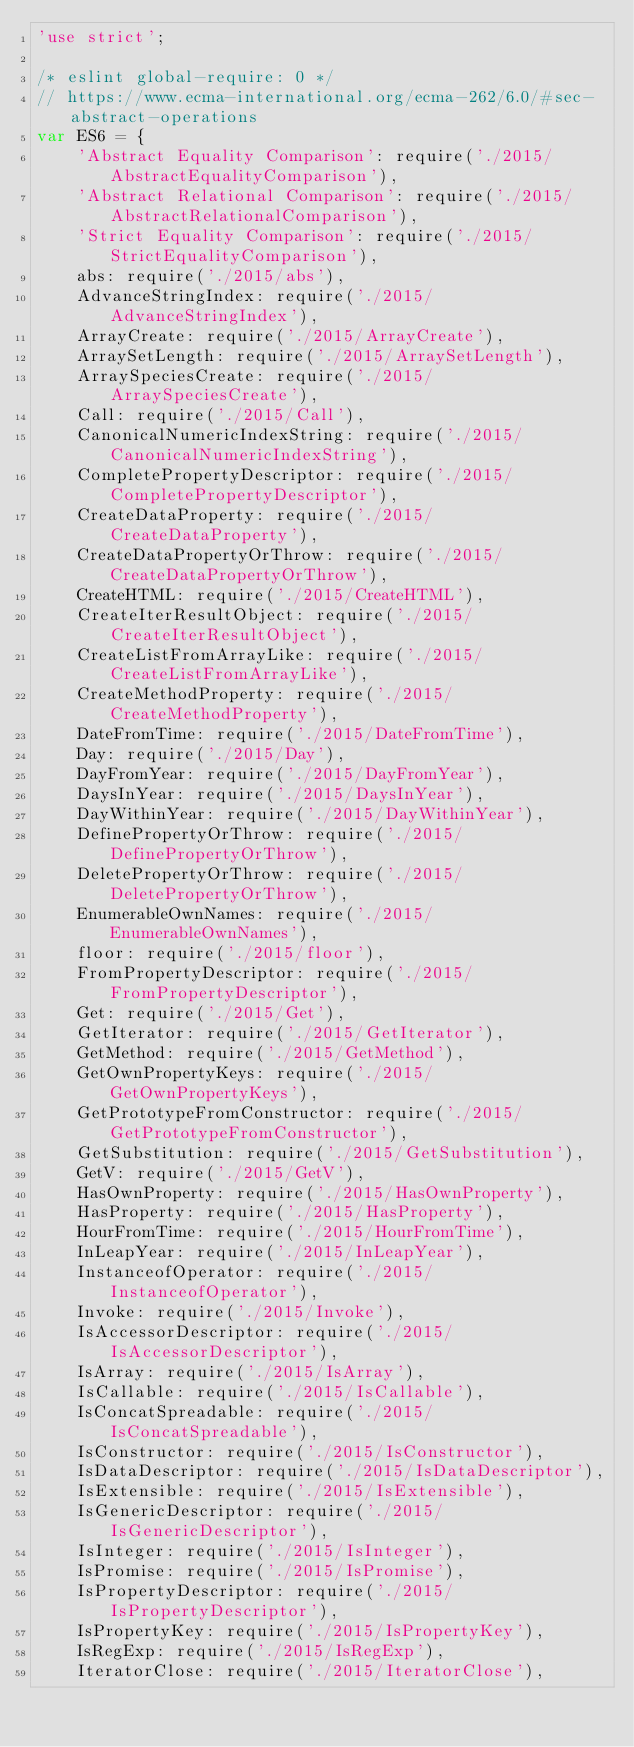<code> <loc_0><loc_0><loc_500><loc_500><_JavaScript_>'use strict';

/* eslint global-require: 0 */
// https://www.ecma-international.org/ecma-262/6.0/#sec-abstract-operations
var ES6 = {
	'Abstract Equality Comparison': require('./2015/AbstractEqualityComparison'),
	'Abstract Relational Comparison': require('./2015/AbstractRelationalComparison'),
	'Strict Equality Comparison': require('./2015/StrictEqualityComparison'),
	abs: require('./2015/abs'),
	AdvanceStringIndex: require('./2015/AdvanceStringIndex'),
	ArrayCreate: require('./2015/ArrayCreate'),
	ArraySetLength: require('./2015/ArraySetLength'),
	ArraySpeciesCreate: require('./2015/ArraySpeciesCreate'),
	Call: require('./2015/Call'),
	CanonicalNumericIndexString: require('./2015/CanonicalNumericIndexString'),
	CompletePropertyDescriptor: require('./2015/CompletePropertyDescriptor'),
	CreateDataProperty: require('./2015/CreateDataProperty'),
	CreateDataPropertyOrThrow: require('./2015/CreateDataPropertyOrThrow'),
	CreateHTML: require('./2015/CreateHTML'),
	CreateIterResultObject: require('./2015/CreateIterResultObject'),
	CreateListFromArrayLike: require('./2015/CreateListFromArrayLike'),
	CreateMethodProperty: require('./2015/CreateMethodProperty'),
	DateFromTime: require('./2015/DateFromTime'),
	Day: require('./2015/Day'),
	DayFromYear: require('./2015/DayFromYear'),
	DaysInYear: require('./2015/DaysInYear'),
	DayWithinYear: require('./2015/DayWithinYear'),
	DefinePropertyOrThrow: require('./2015/DefinePropertyOrThrow'),
	DeletePropertyOrThrow: require('./2015/DeletePropertyOrThrow'),
	EnumerableOwnNames: require('./2015/EnumerableOwnNames'),
	floor: require('./2015/floor'),
	FromPropertyDescriptor: require('./2015/FromPropertyDescriptor'),
	Get: require('./2015/Get'),
	GetIterator: require('./2015/GetIterator'),
	GetMethod: require('./2015/GetMethod'),
	GetOwnPropertyKeys: require('./2015/GetOwnPropertyKeys'),
	GetPrototypeFromConstructor: require('./2015/GetPrototypeFromConstructor'),
	GetSubstitution: require('./2015/GetSubstitution'),
	GetV: require('./2015/GetV'),
	HasOwnProperty: require('./2015/HasOwnProperty'),
	HasProperty: require('./2015/HasProperty'),
	HourFromTime: require('./2015/HourFromTime'),
	InLeapYear: require('./2015/InLeapYear'),
	InstanceofOperator: require('./2015/InstanceofOperator'),
	Invoke: require('./2015/Invoke'),
	IsAccessorDescriptor: require('./2015/IsAccessorDescriptor'),
	IsArray: require('./2015/IsArray'),
	IsCallable: require('./2015/IsCallable'),
	IsConcatSpreadable: require('./2015/IsConcatSpreadable'),
	IsConstructor: require('./2015/IsConstructor'),
	IsDataDescriptor: require('./2015/IsDataDescriptor'),
	IsExtensible: require('./2015/IsExtensible'),
	IsGenericDescriptor: require('./2015/IsGenericDescriptor'),
	IsInteger: require('./2015/IsInteger'),
	IsPromise: require('./2015/IsPromise'),
	IsPropertyDescriptor: require('./2015/IsPropertyDescriptor'),
	IsPropertyKey: require('./2015/IsPropertyKey'),
	IsRegExp: require('./2015/IsRegExp'),
	IteratorClose: require('./2015/IteratorClose'),</code> 